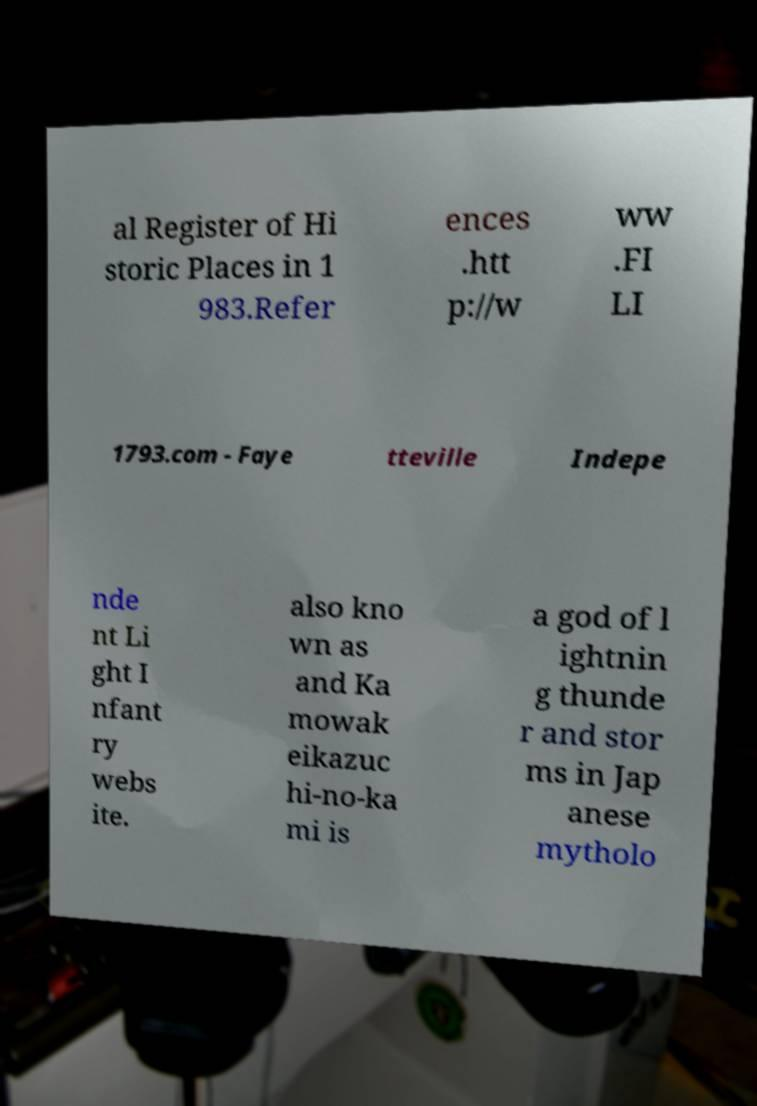Could you assist in decoding the text presented in this image and type it out clearly? al Register of Hi storic Places in 1 983.Refer ences .htt p://w ww .FI LI 1793.com - Faye tteville Indepe nde nt Li ght I nfant ry webs ite. also kno wn as and Ka mowak eikazuc hi-no-ka mi is a god of l ightnin g thunde r and stor ms in Jap anese mytholo 